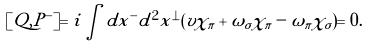Convert formula to latex. <formula><loc_0><loc_0><loc_500><loc_500>[ Q , P ^ { - } ] = i \int d x ^ { - } d ^ { 2 } x ^ { \bot } ( v \chi _ { \pi } + \omega _ { \sigma } \chi _ { \pi } - \omega _ { \pi } \chi _ { \sigma } ) = 0 .</formula> 